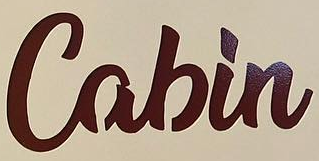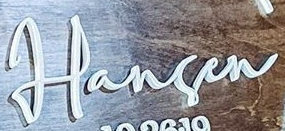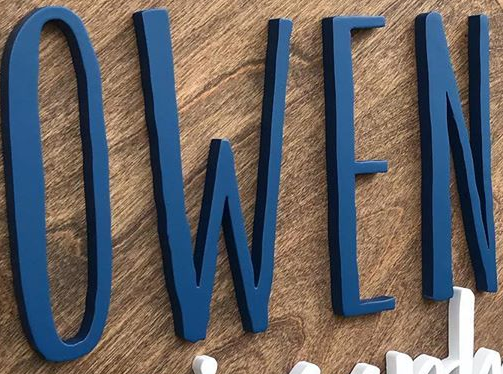What text is displayed in these images sequentially, separated by a semicolon? Cabin; Harsen; OWEN 